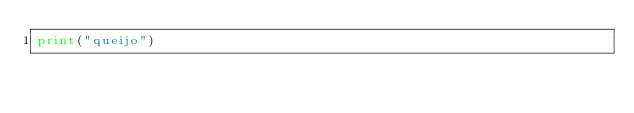<code> <loc_0><loc_0><loc_500><loc_500><_Python_>print("queijo")</code> 